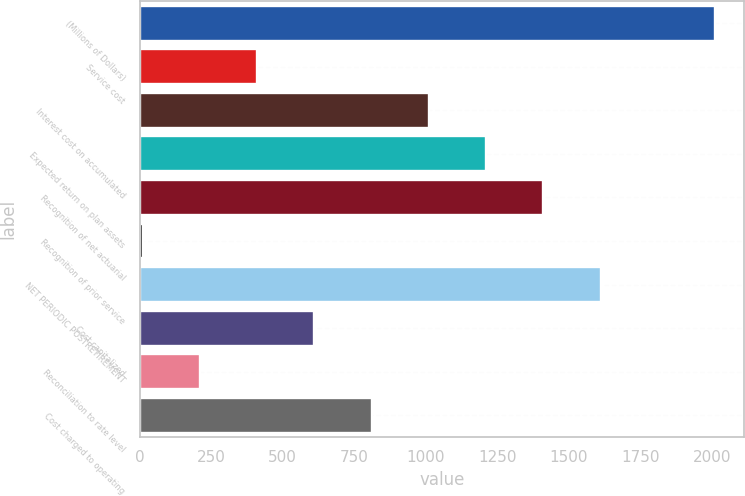Convert chart. <chart><loc_0><loc_0><loc_500><loc_500><bar_chart><fcel>(Millions of Dollars)<fcel>Service cost<fcel>Interest cost on accumulated<fcel>Expected return on plan assets<fcel>Recognition of net actuarial<fcel>Recognition of prior service<fcel>NET PERIODIC POSTRETIREMENT<fcel>Cost capitalized<fcel>Reconciliation to rate level<fcel>Cost charged to operating<nl><fcel>2011<fcel>411<fcel>1011<fcel>1211<fcel>1411<fcel>11<fcel>1611<fcel>611<fcel>211<fcel>811<nl></chart> 